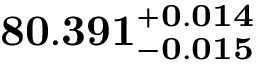Convert formula to latex. <formula><loc_0><loc_0><loc_500><loc_500>8 0 . 3 9 1 _ { - 0 . 0 1 5 } ^ { + 0 . 0 1 4 }</formula> 